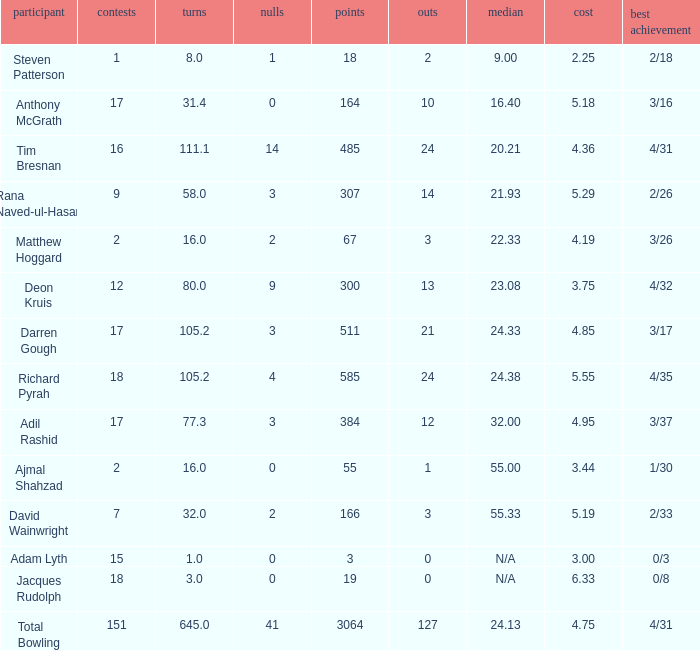What is the lowest Overs with a Run that is 18? 8.0. 